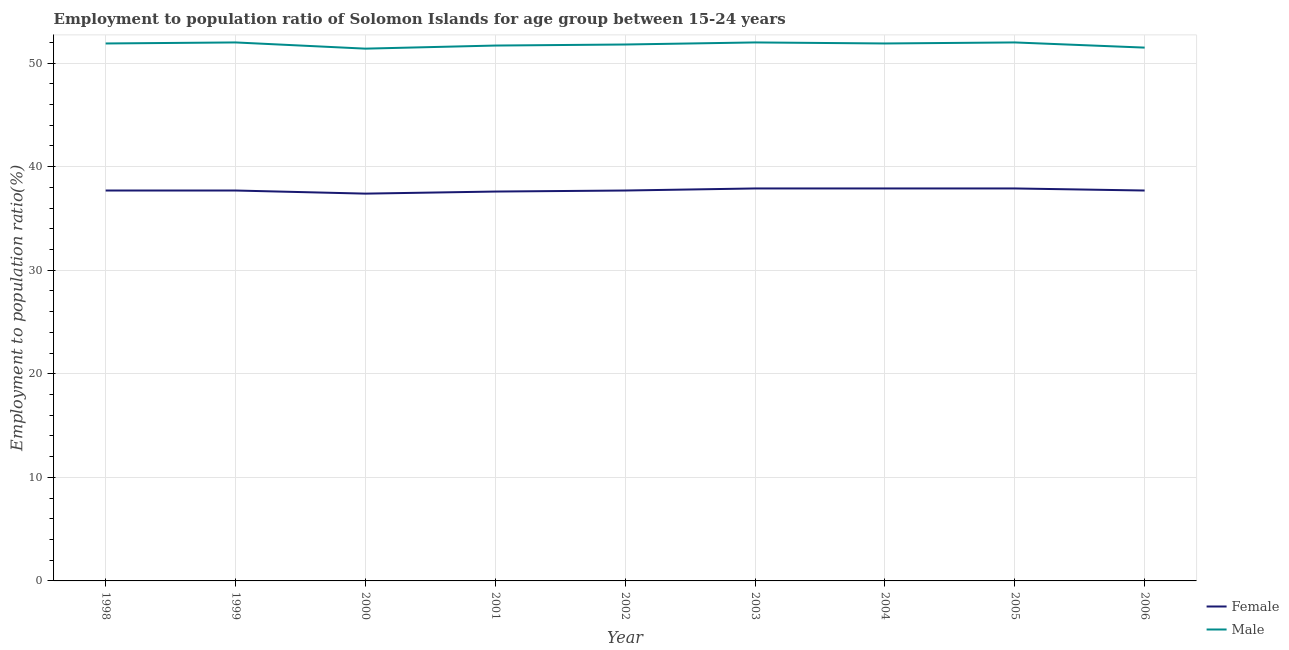Does the line corresponding to employment to population ratio(male) intersect with the line corresponding to employment to population ratio(female)?
Provide a succinct answer. No. Is the number of lines equal to the number of legend labels?
Your answer should be compact. Yes. What is the employment to population ratio(male) in 2002?
Keep it short and to the point. 51.8. Across all years, what is the maximum employment to population ratio(female)?
Give a very brief answer. 37.9. Across all years, what is the minimum employment to population ratio(female)?
Your response must be concise. 37.4. In which year was the employment to population ratio(female) minimum?
Your answer should be compact. 2000. What is the total employment to population ratio(female) in the graph?
Your answer should be very brief. 339.5. What is the difference between the employment to population ratio(male) in 2001 and that in 2004?
Offer a terse response. -0.2. What is the difference between the employment to population ratio(female) in 2004 and the employment to population ratio(male) in 2002?
Ensure brevity in your answer.  -13.9. What is the average employment to population ratio(male) per year?
Keep it short and to the point. 51.8. In the year 1999, what is the difference between the employment to population ratio(female) and employment to population ratio(male)?
Keep it short and to the point. -14.3. What is the ratio of the employment to population ratio(female) in 1998 to that in 2003?
Your answer should be compact. 0.99. In how many years, is the employment to population ratio(female) greater than the average employment to population ratio(female) taken over all years?
Offer a terse response. 3. Does the employment to population ratio(male) monotonically increase over the years?
Offer a very short reply. No. Is the employment to population ratio(male) strictly greater than the employment to population ratio(female) over the years?
Provide a succinct answer. Yes. How many lines are there?
Ensure brevity in your answer.  2. How many years are there in the graph?
Your response must be concise. 9. Does the graph contain any zero values?
Make the answer very short. No. Does the graph contain grids?
Keep it short and to the point. Yes. How are the legend labels stacked?
Your answer should be very brief. Vertical. What is the title of the graph?
Your answer should be compact. Employment to population ratio of Solomon Islands for age group between 15-24 years. What is the label or title of the X-axis?
Give a very brief answer. Year. What is the Employment to population ratio(%) of Female in 1998?
Provide a short and direct response. 37.7. What is the Employment to population ratio(%) of Male in 1998?
Offer a very short reply. 51.9. What is the Employment to population ratio(%) of Female in 1999?
Ensure brevity in your answer.  37.7. What is the Employment to population ratio(%) of Female in 2000?
Keep it short and to the point. 37.4. What is the Employment to population ratio(%) in Male in 2000?
Keep it short and to the point. 51.4. What is the Employment to population ratio(%) of Female in 2001?
Provide a succinct answer. 37.6. What is the Employment to population ratio(%) of Male in 2001?
Ensure brevity in your answer.  51.7. What is the Employment to population ratio(%) of Female in 2002?
Your answer should be compact. 37.7. What is the Employment to population ratio(%) in Male in 2002?
Ensure brevity in your answer.  51.8. What is the Employment to population ratio(%) in Female in 2003?
Offer a very short reply. 37.9. What is the Employment to population ratio(%) in Male in 2003?
Make the answer very short. 52. What is the Employment to population ratio(%) of Female in 2004?
Offer a terse response. 37.9. What is the Employment to population ratio(%) in Male in 2004?
Your response must be concise. 51.9. What is the Employment to population ratio(%) in Female in 2005?
Ensure brevity in your answer.  37.9. What is the Employment to population ratio(%) of Female in 2006?
Your answer should be compact. 37.7. What is the Employment to population ratio(%) of Male in 2006?
Offer a very short reply. 51.5. Across all years, what is the maximum Employment to population ratio(%) in Female?
Your answer should be very brief. 37.9. Across all years, what is the minimum Employment to population ratio(%) in Female?
Your answer should be compact. 37.4. Across all years, what is the minimum Employment to population ratio(%) in Male?
Make the answer very short. 51.4. What is the total Employment to population ratio(%) of Female in the graph?
Your answer should be very brief. 339.5. What is the total Employment to population ratio(%) of Male in the graph?
Give a very brief answer. 466.2. What is the difference between the Employment to population ratio(%) in Female in 1998 and that in 1999?
Your answer should be compact. 0. What is the difference between the Employment to population ratio(%) of Male in 1998 and that in 1999?
Offer a very short reply. -0.1. What is the difference between the Employment to population ratio(%) in Male in 1998 and that in 2001?
Offer a very short reply. 0.2. What is the difference between the Employment to population ratio(%) of Female in 1998 and that in 2002?
Provide a succinct answer. 0. What is the difference between the Employment to population ratio(%) in Female in 1998 and that in 2003?
Provide a succinct answer. -0.2. What is the difference between the Employment to population ratio(%) in Male in 1998 and that in 2003?
Provide a short and direct response. -0.1. What is the difference between the Employment to population ratio(%) of Male in 1998 and that in 2004?
Ensure brevity in your answer.  0. What is the difference between the Employment to population ratio(%) in Female in 1998 and that in 2006?
Your answer should be compact. 0. What is the difference between the Employment to population ratio(%) in Male in 1998 and that in 2006?
Your answer should be compact. 0.4. What is the difference between the Employment to population ratio(%) of Female in 1999 and that in 2001?
Provide a short and direct response. 0.1. What is the difference between the Employment to population ratio(%) in Male in 1999 and that in 2001?
Ensure brevity in your answer.  0.3. What is the difference between the Employment to population ratio(%) in Male in 1999 and that in 2003?
Give a very brief answer. 0. What is the difference between the Employment to population ratio(%) in Female in 1999 and that in 2006?
Your answer should be compact. 0. What is the difference between the Employment to population ratio(%) of Male in 2000 and that in 2001?
Your answer should be very brief. -0.3. What is the difference between the Employment to population ratio(%) of Female in 2000 and that in 2004?
Provide a succinct answer. -0.5. What is the difference between the Employment to population ratio(%) in Female in 2000 and that in 2005?
Provide a short and direct response. -0.5. What is the difference between the Employment to population ratio(%) of Female in 2000 and that in 2006?
Offer a terse response. -0.3. What is the difference between the Employment to population ratio(%) of Female in 2001 and that in 2002?
Make the answer very short. -0.1. What is the difference between the Employment to population ratio(%) in Male in 2001 and that in 2002?
Your response must be concise. -0.1. What is the difference between the Employment to population ratio(%) in Male in 2001 and that in 2003?
Your answer should be very brief. -0.3. What is the difference between the Employment to population ratio(%) of Male in 2001 and that in 2004?
Provide a succinct answer. -0.2. What is the difference between the Employment to population ratio(%) in Female in 2001 and that in 2005?
Provide a succinct answer. -0.3. What is the difference between the Employment to population ratio(%) in Female in 2001 and that in 2006?
Ensure brevity in your answer.  -0.1. What is the difference between the Employment to population ratio(%) of Female in 2002 and that in 2003?
Ensure brevity in your answer.  -0.2. What is the difference between the Employment to population ratio(%) in Male in 2002 and that in 2004?
Offer a terse response. -0.1. What is the difference between the Employment to population ratio(%) in Female in 2002 and that in 2005?
Your answer should be compact. -0.2. What is the difference between the Employment to population ratio(%) in Female in 2003 and that in 2004?
Your response must be concise. 0. What is the difference between the Employment to population ratio(%) of Male in 2003 and that in 2004?
Provide a succinct answer. 0.1. What is the difference between the Employment to population ratio(%) in Female in 2003 and that in 2005?
Provide a succinct answer. 0. What is the difference between the Employment to population ratio(%) in Male in 2004 and that in 2005?
Provide a succinct answer. -0.1. What is the difference between the Employment to population ratio(%) in Male in 2004 and that in 2006?
Your answer should be very brief. 0.4. What is the difference between the Employment to population ratio(%) of Female in 2005 and that in 2006?
Keep it short and to the point. 0.2. What is the difference between the Employment to population ratio(%) in Male in 2005 and that in 2006?
Offer a very short reply. 0.5. What is the difference between the Employment to population ratio(%) of Female in 1998 and the Employment to population ratio(%) of Male in 1999?
Your answer should be compact. -14.3. What is the difference between the Employment to population ratio(%) in Female in 1998 and the Employment to population ratio(%) in Male in 2000?
Offer a terse response. -13.7. What is the difference between the Employment to population ratio(%) of Female in 1998 and the Employment to population ratio(%) of Male in 2001?
Your answer should be very brief. -14. What is the difference between the Employment to population ratio(%) in Female in 1998 and the Employment to population ratio(%) in Male in 2002?
Ensure brevity in your answer.  -14.1. What is the difference between the Employment to population ratio(%) in Female in 1998 and the Employment to population ratio(%) in Male in 2003?
Offer a very short reply. -14.3. What is the difference between the Employment to population ratio(%) of Female in 1998 and the Employment to population ratio(%) of Male in 2005?
Make the answer very short. -14.3. What is the difference between the Employment to population ratio(%) in Female in 1998 and the Employment to population ratio(%) in Male in 2006?
Ensure brevity in your answer.  -13.8. What is the difference between the Employment to population ratio(%) of Female in 1999 and the Employment to population ratio(%) of Male in 2000?
Ensure brevity in your answer.  -13.7. What is the difference between the Employment to population ratio(%) of Female in 1999 and the Employment to population ratio(%) of Male in 2001?
Offer a very short reply. -14. What is the difference between the Employment to population ratio(%) in Female in 1999 and the Employment to population ratio(%) in Male in 2002?
Make the answer very short. -14.1. What is the difference between the Employment to population ratio(%) of Female in 1999 and the Employment to population ratio(%) of Male in 2003?
Give a very brief answer. -14.3. What is the difference between the Employment to population ratio(%) in Female in 1999 and the Employment to population ratio(%) in Male in 2005?
Keep it short and to the point. -14.3. What is the difference between the Employment to population ratio(%) in Female in 1999 and the Employment to population ratio(%) in Male in 2006?
Your answer should be very brief. -13.8. What is the difference between the Employment to population ratio(%) of Female in 2000 and the Employment to population ratio(%) of Male in 2001?
Make the answer very short. -14.3. What is the difference between the Employment to population ratio(%) of Female in 2000 and the Employment to population ratio(%) of Male in 2002?
Offer a very short reply. -14.4. What is the difference between the Employment to population ratio(%) of Female in 2000 and the Employment to population ratio(%) of Male in 2003?
Your response must be concise. -14.6. What is the difference between the Employment to population ratio(%) of Female in 2000 and the Employment to population ratio(%) of Male in 2004?
Provide a succinct answer. -14.5. What is the difference between the Employment to population ratio(%) of Female in 2000 and the Employment to population ratio(%) of Male in 2005?
Your response must be concise. -14.6. What is the difference between the Employment to population ratio(%) of Female in 2000 and the Employment to population ratio(%) of Male in 2006?
Your answer should be very brief. -14.1. What is the difference between the Employment to population ratio(%) of Female in 2001 and the Employment to population ratio(%) of Male in 2003?
Offer a very short reply. -14.4. What is the difference between the Employment to population ratio(%) in Female in 2001 and the Employment to population ratio(%) in Male in 2004?
Your answer should be very brief. -14.3. What is the difference between the Employment to population ratio(%) in Female in 2001 and the Employment to population ratio(%) in Male in 2005?
Make the answer very short. -14.4. What is the difference between the Employment to population ratio(%) in Female in 2002 and the Employment to population ratio(%) in Male in 2003?
Provide a short and direct response. -14.3. What is the difference between the Employment to population ratio(%) in Female in 2002 and the Employment to population ratio(%) in Male in 2005?
Ensure brevity in your answer.  -14.3. What is the difference between the Employment to population ratio(%) in Female in 2003 and the Employment to population ratio(%) in Male in 2004?
Keep it short and to the point. -14. What is the difference between the Employment to population ratio(%) of Female in 2003 and the Employment to population ratio(%) of Male in 2005?
Give a very brief answer. -14.1. What is the difference between the Employment to population ratio(%) in Female in 2004 and the Employment to population ratio(%) in Male in 2005?
Your answer should be very brief. -14.1. What is the average Employment to population ratio(%) of Female per year?
Your response must be concise. 37.72. What is the average Employment to population ratio(%) of Male per year?
Provide a succinct answer. 51.8. In the year 1999, what is the difference between the Employment to population ratio(%) of Female and Employment to population ratio(%) of Male?
Offer a terse response. -14.3. In the year 2001, what is the difference between the Employment to population ratio(%) of Female and Employment to population ratio(%) of Male?
Offer a very short reply. -14.1. In the year 2002, what is the difference between the Employment to population ratio(%) in Female and Employment to population ratio(%) in Male?
Ensure brevity in your answer.  -14.1. In the year 2003, what is the difference between the Employment to population ratio(%) of Female and Employment to population ratio(%) of Male?
Keep it short and to the point. -14.1. In the year 2004, what is the difference between the Employment to population ratio(%) in Female and Employment to population ratio(%) in Male?
Your answer should be very brief. -14. In the year 2005, what is the difference between the Employment to population ratio(%) of Female and Employment to population ratio(%) of Male?
Offer a very short reply. -14.1. In the year 2006, what is the difference between the Employment to population ratio(%) of Female and Employment to population ratio(%) of Male?
Your response must be concise. -13.8. What is the ratio of the Employment to population ratio(%) in Female in 1998 to that in 1999?
Keep it short and to the point. 1. What is the ratio of the Employment to population ratio(%) in Female in 1998 to that in 2000?
Your answer should be very brief. 1.01. What is the ratio of the Employment to population ratio(%) in Male in 1998 to that in 2000?
Make the answer very short. 1.01. What is the ratio of the Employment to population ratio(%) of Male in 1998 to that in 2002?
Your answer should be compact. 1. What is the ratio of the Employment to population ratio(%) in Male in 1998 to that in 2003?
Keep it short and to the point. 1. What is the ratio of the Employment to population ratio(%) of Female in 1998 to that in 2006?
Your response must be concise. 1. What is the ratio of the Employment to population ratio(%) of Female in 1999 to that in 2000?
Your answer should be compact. 1.01. What is the ratio of the Employment to population ratio(%) in Male in 1999 to that in 2000?
Make the answer very short. 1.01. What is the ratio of the Employment to population ratio(%) in Female in 1999 to that in 2002?
Provide a short and direct response. 1. What is the ratio of the Employment to population ratio(%) in Male in 1999 to that in 2002?
Make the answer very short. 1. What is the ratio of the Employment to population ratio(%) in Male in 1999 to that in 2003?
Ensure brevity in your answer.  1. What is the ratio of the Employment to population ratio(%) in Female in 1999 to that in 2005?
Provide a succinct answer. 0.99. What is the ratio of the Employment to population ratio(%) in Male in 1999 to that in 2005?
Offer a very short reply. 1. What is the ratio of the Employment to population ratio(%) in Male in 1999 to that in 2006?
Provide a short and direct response. 1.01. What is the ratio of the Employment to population ratio(%) in Female in 2000 to that in 2001?
Make the answer very short. 0.99. What is the ratio of the Employment to population ratio(%) in Male in 2000 to that in 2001?
Give a very brief answer. 0.99. What is the ratio of the Employment to population ratio(%) of Male in 2000 to that in 2002?
Make the answer very short. 0.99. What is the ratio of the Employment to population ratio(%) in Female in 2000 to that in 2003?
Give a very brief answer. 0.99. What is the ratio of the Employment to population ratio(%) of Male in 2000 to that in 2003?
Offer a terse response. 0.99. What is the ratio of the Employment to population ratio(%) of Female in 2000 to that in 2004?
Offer a very short reply. 0.99. What is the ratio of the Employment to population ratio(%) in Male in 2000 to that in 2004?
Offer a very short reply. 0.99. What is the ratio of the Employment to population ratio(%) of Male in 2000 to that in 2005?
Provide a succinct answer. 0.99. What is the ratio of the Employment to population ratio(%) in Male in 2000 to that in 2006?
Offer a terse response. 1. What is the ratio of the Employment to population ratio(%) in Female in 2001 to that in 2002?
Ensure brevity in your answer.  1. What is the ratio of the Employment to population ratio(%) of Male in 2001 to that in 2002?
Provide a succinct answer. 1. What is the ratio of the Employment to population ratio(%) in Male in 2001 to that in 2003?
Offer a very short reply. 0.99. What is the ratio of the Employment to population ratio(%) of Male in 2001 to that in 2004?
Offer a terse response. 1. What is the ratio of the Employment to population ratio(%) of Female in 2001 to that in 2005?
Offer a terse response. 0.99. What is the ratio of the Employment to population ratio(%) in Female in 2001 to that in 2006?
Your answer should be compact. 1. What is the ratio of the Employment to population ratio(%) in Female in 2002 to that in 2004?
Offer a terse response. 0.99. What is the ratio of the Employment to population ratio(%) in Male in 2002 to that in 2005?
Your answer should be compact. 1. What is the ratio of the Employment to population ratio(%) in Male in 2002 to that in 2006?
Your answer should be compact. 1.01. What is the ratio of the Employment to population ratio(%) in Female in 2003 to that in 2004?
Make the answer very short. 1. What is the ratio of the Employment to population ratio(%) in Female in 2003 to that in 2005?
Ensure brevity in your answer.  1. What is the ratio of the Employment to population ratio(%) in Female in 2003 to that in 2006?
Offer a very short reply. 1.01. What is the ratio of the Employment to population ratio(%) in Male in 2003 to that in 2006?
Offer a very short reply. 1.01. What is the ratio of the Employment to population ratio(%) in Male in 2004 to that in 2005?
Offer a very short reply. 1. What is the ratio of the Employment to population ratio(%) of Female in 2004 to that in 2006?
Offer a very short reply. 1.01. What is the ratio of the Employment to population ratio(%) in Male in 2004 to that in 2006?
Provide a succinct answer. 1.01. What is the ratio of the Employment to population ratio(%) of Male in 2005 to that in 2006?
Provide a short and direct response. 1.01. What is the difference between the highest and the second highest Employment to population ratio(%) of Male?
Your answer should be very brief. 0. What is the difference between the highest and the lowest Employment to population ratio(%) in Male?
Your answer should be very brief. 0.6. 